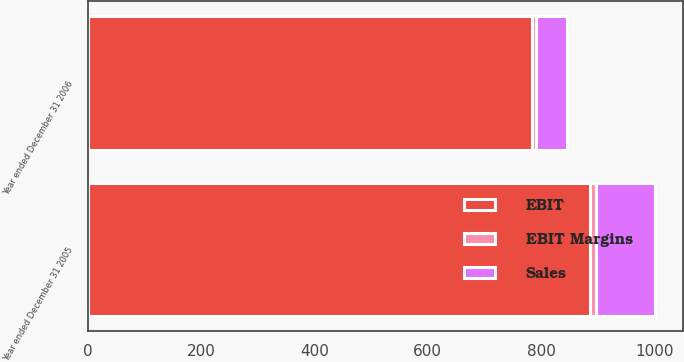<chart> <loc_0><loc_0><loc_500><loc_500><stacked_bar_chart><ecel><fcel>Year ended December 31 2006<fcel>Year ended December 31 2005<nl><fcel>EBIT<fcel>784<fcel>886<nl><fcel>Sales<fcel>55<fcel>103<nl><fcel>EBIT Margins<fcel>7<fcel>11.8<nl></chart> 